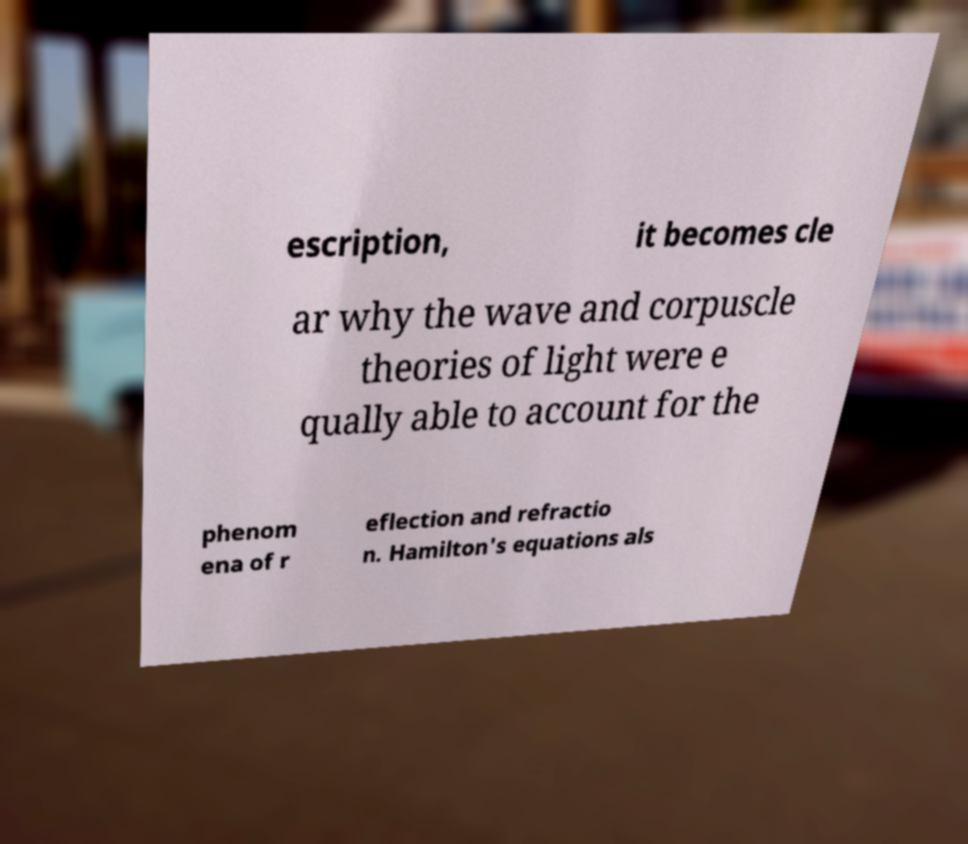Could you assist in decoding the text presented in this image and type it out clearly? escription, it becomes cle ar why the wave and corpuscle theories of light were e qually able to account for the phenom ena of r eflection and refractio n. Hamilton's equations als 